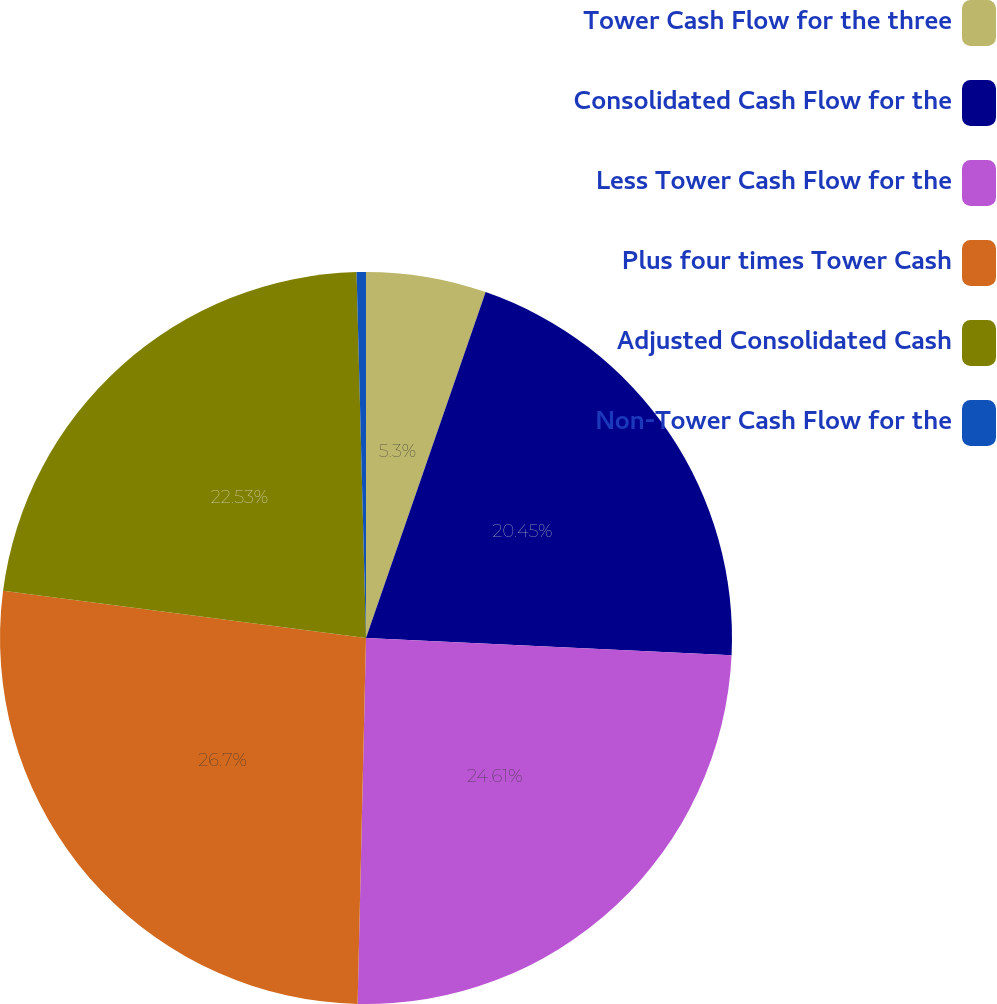Convert chart. <chart><loc_0><loc_0><loc_500><loc_500><pie_chart><fcel>Tower Cash Flow for the three<fcel>Consolidated Cash Flow for the<fcel>Less Tower Cash Flow for the<fcel>Plus four times Tower Cash<fcel>Adjusted Consolidated Cash<fcel>Non-Tower Cash Flow for the<nl><fcel>5.3%<fcel>20.45%<fcel>24.61%<fcel>26.69%<fcel>22.53%<fcel>0.41%<nl></chart> 